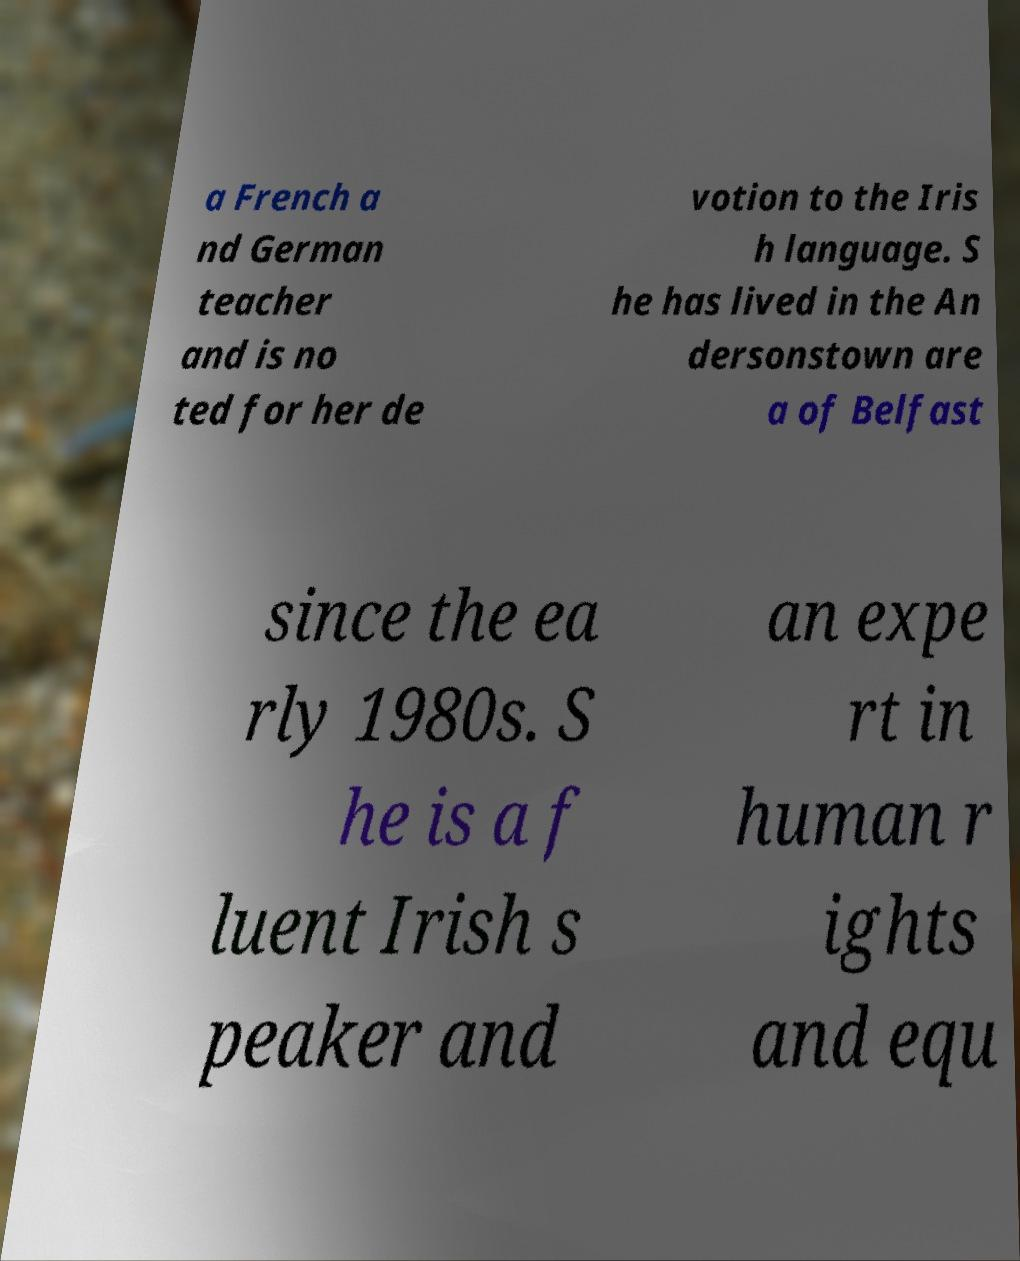What messages or text are displayed in this image? I need them in a readable, typed format. a French a nd German teacher and is no ted for her de votion to the Iris h language. S he has lived in the An dersonstown are a of Belfast since the ea rly 1980s. S he is a f luent Irish s peaker and an expe rt in human r ights and equ 